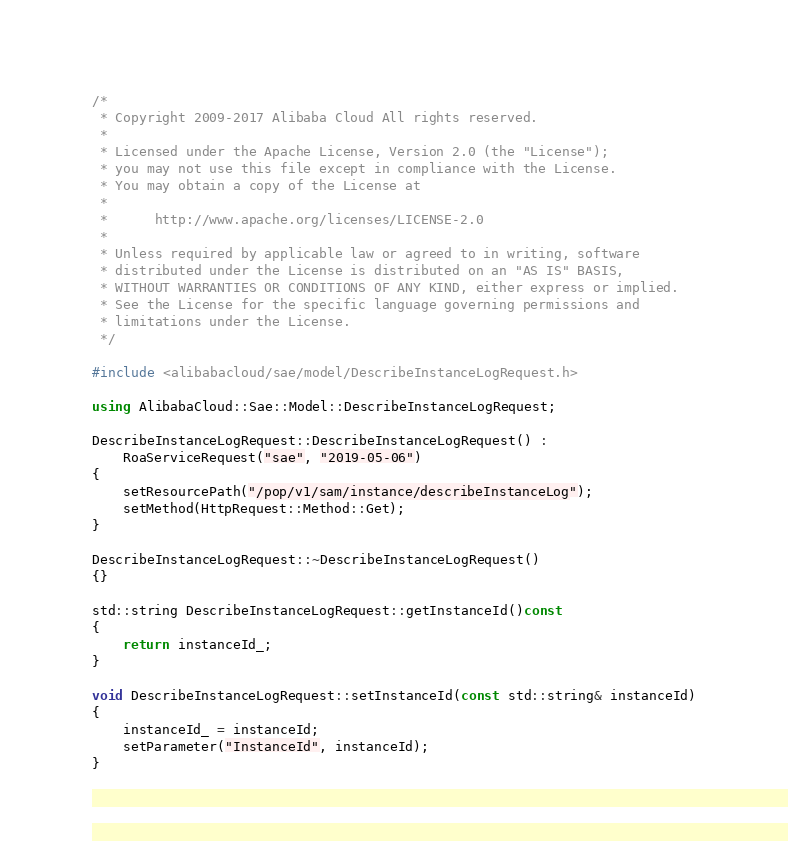Convert code to text. <code><loc_0><loc_0><loc_500><loc_500><_C++_>/*
 * Copyright 2009-2017 Alibaba Cloud All rights reserved.
 * 
 * Licensed under the Apache License, Version 2.0 (the "License");
 * you may not use this file except in compliance with the License.
 * You may obtain a copy of the License at
 * 
 *      http://www.apache.org/licenses/LICENSE-2.0
 * 
 * Unless required by applicable law or agreed to in writing, software
 * distributed under the License is distributed on an "AS IS" BASIS,
 * WITHOUT WARRANTIES OR CONDITIONS OF ANY KIND, either express or implied.
 * See the License for the specific language governing permissions and
 * limitations under the License.
 */

#include <alibabacloud/sae/model/DescribeInstanceLogRequest.h>

using AlibabaCloud::Sae::Model::DescribeInstanceLogRequest;

DescribeInstanceLogRequest::DescribeInstanceLogRequest() :
	RoaServiceRequest("sae", "2019-05-06")
{
	setResourcePath("/pop/v1/sam/instance/describeInstanceLog");
	setMethod(HttpRequest::Method::Get);
}

DescribeInstanceLogRequest::~DescribeInstanceLogRequest()
{}

std::string DescribeInstanceLogRequest::getInstanceId()const
{
	return instanceId_;
}

void DescribeInstanceLogRequest::setInstanceId(const std::string& instanceId)
{
	instanceId_ = instanceId;
	setParameter("InstanceId", instanceId);
}

</code> 